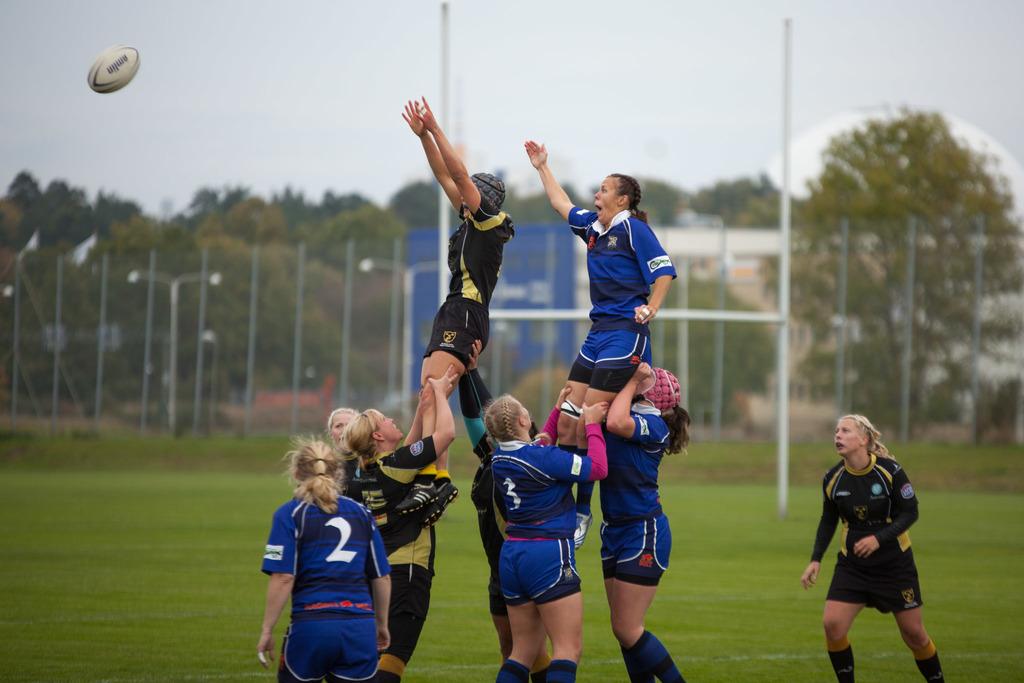Playing rugby or baseball?
Your answer should be very brief. Answering does not require reading text in the image. What is the girl's jersey number on the blue and white team standing on the left side?
Provide a short and direct response. 2. 